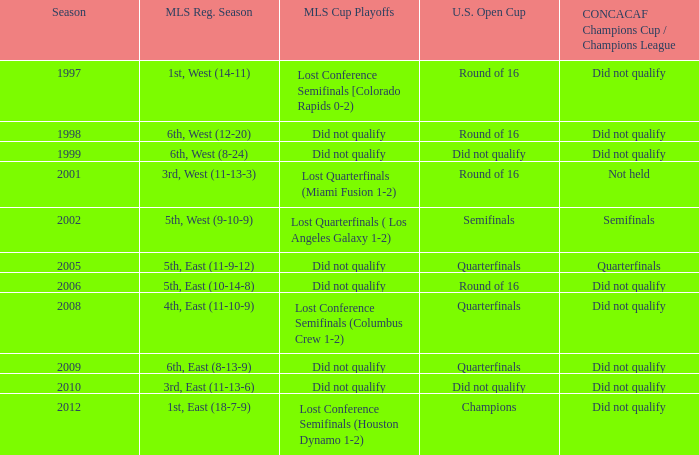Could you help me parse every detail presented in this table? {'header': ['Season', 'MLS Reg. Season', 'MLS Cup Playoffs', 'U.S. Open Cup', 'CONCACAF Champions Cup / Champions League'], 'rows': [['1997', '1st, West (14-11)', 'Lost Conference Semifinals [Colorado Rapids 0-2)', 'Round of 16', 'Did not qualify'], ['1998', '6th, West (12-20)', 'Did not qualify', 'Round of 16', 'Did not qualify'], ['1999', '6th, West (8-24)', 'Did not qualify', 'Did not qualify', 'Did not qualify'], ['2001', '3rd, West (11-13-3)', 'Lost Quarterfinals (Miami Fusion 1-2)', 'Round of 16', 'Not held'], ['2002', '5th, West (9-10-9)', 'Lost Quarterfinals ( Los Angeles Galaxy 1-2)', 'Semifinals', 'Semifinals'], ['2005', '5th, East (11-9-12)', 'Did not qualify', 'Quarterfinals', 'Quarterfinals'], ['2006', '5th, East (10-14-8)', 'Did not qualify', 'Round of 16', 'Did not qualify'], ['2008', '4th, East (11-10-9)', 'Lost Conference Semifinals (Columbus Crew 1-2)', 'Quarterfinals', 'Did not qualify'], ['2009', '6th, East (8-13-9)', 'Did not qualify', 'Quarterfinals', 'Did not qualify'], ['2010', '3rd, East (11-13-6)', 'Did not qualify', 'Did not qualify', 'Did not qualify'], ['2012', '1st, East (18-7-9)', 'Lost Conference Semifinals (Houston Dynamo 1-2)', 'Champions', 'Did not qualify']]} What were the placements of the team in regular season when they reached quarterfinals in the U.S. Open Cup but did not qualify for the Concaf Champions Cup? 4th, East (11-10-9), 6th, East (8-13-9). 